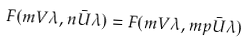Convert formula to latex. <formula><loc_0><loc_0><loc_500><loc_500>F ( m V \lambda , n \bar { U } \lambda ) = F ( m V \lambda , m p \bar { U } \lambda )</formula> 